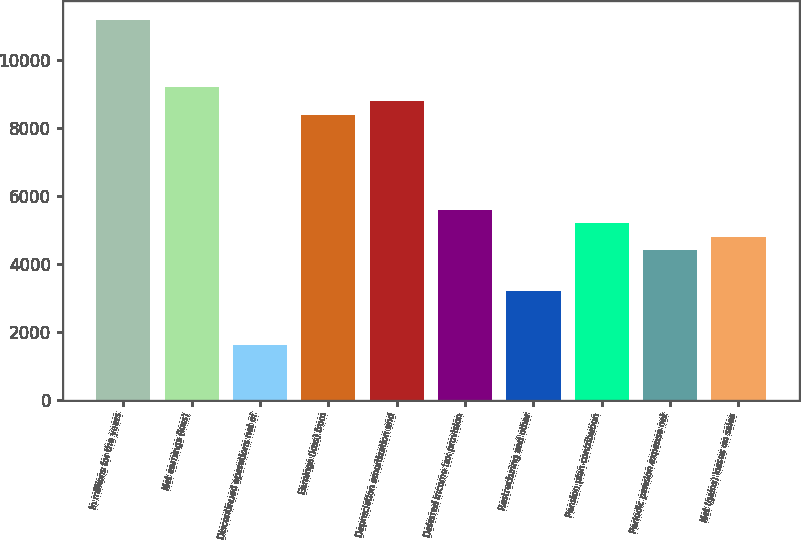<chart> <loc_0><loc_0><loc_500><loc_500><bar_chart><fcel>In millions for the years<fcel>Net earnings (loss)<fcel>Discontinued operations net of<fcel>Earnings (loss) from<fcel>Depreciation amortization and<fcel>Deferred income tax provision<fcel>Restructuring and other<fcel>Pension plan contribution<fcel>Periodic pension expense net<fcel>Net (gains) losses on sales<nl><fcel>11172.4<fcel>9178.4<fcel>1601.2<fcel>8380.8<fcel>8779.6<fcel>5589.2<fcel>3196.4<fcel>5190.4<fcel>4392.8<fcel>4791.6<nl></chart> 